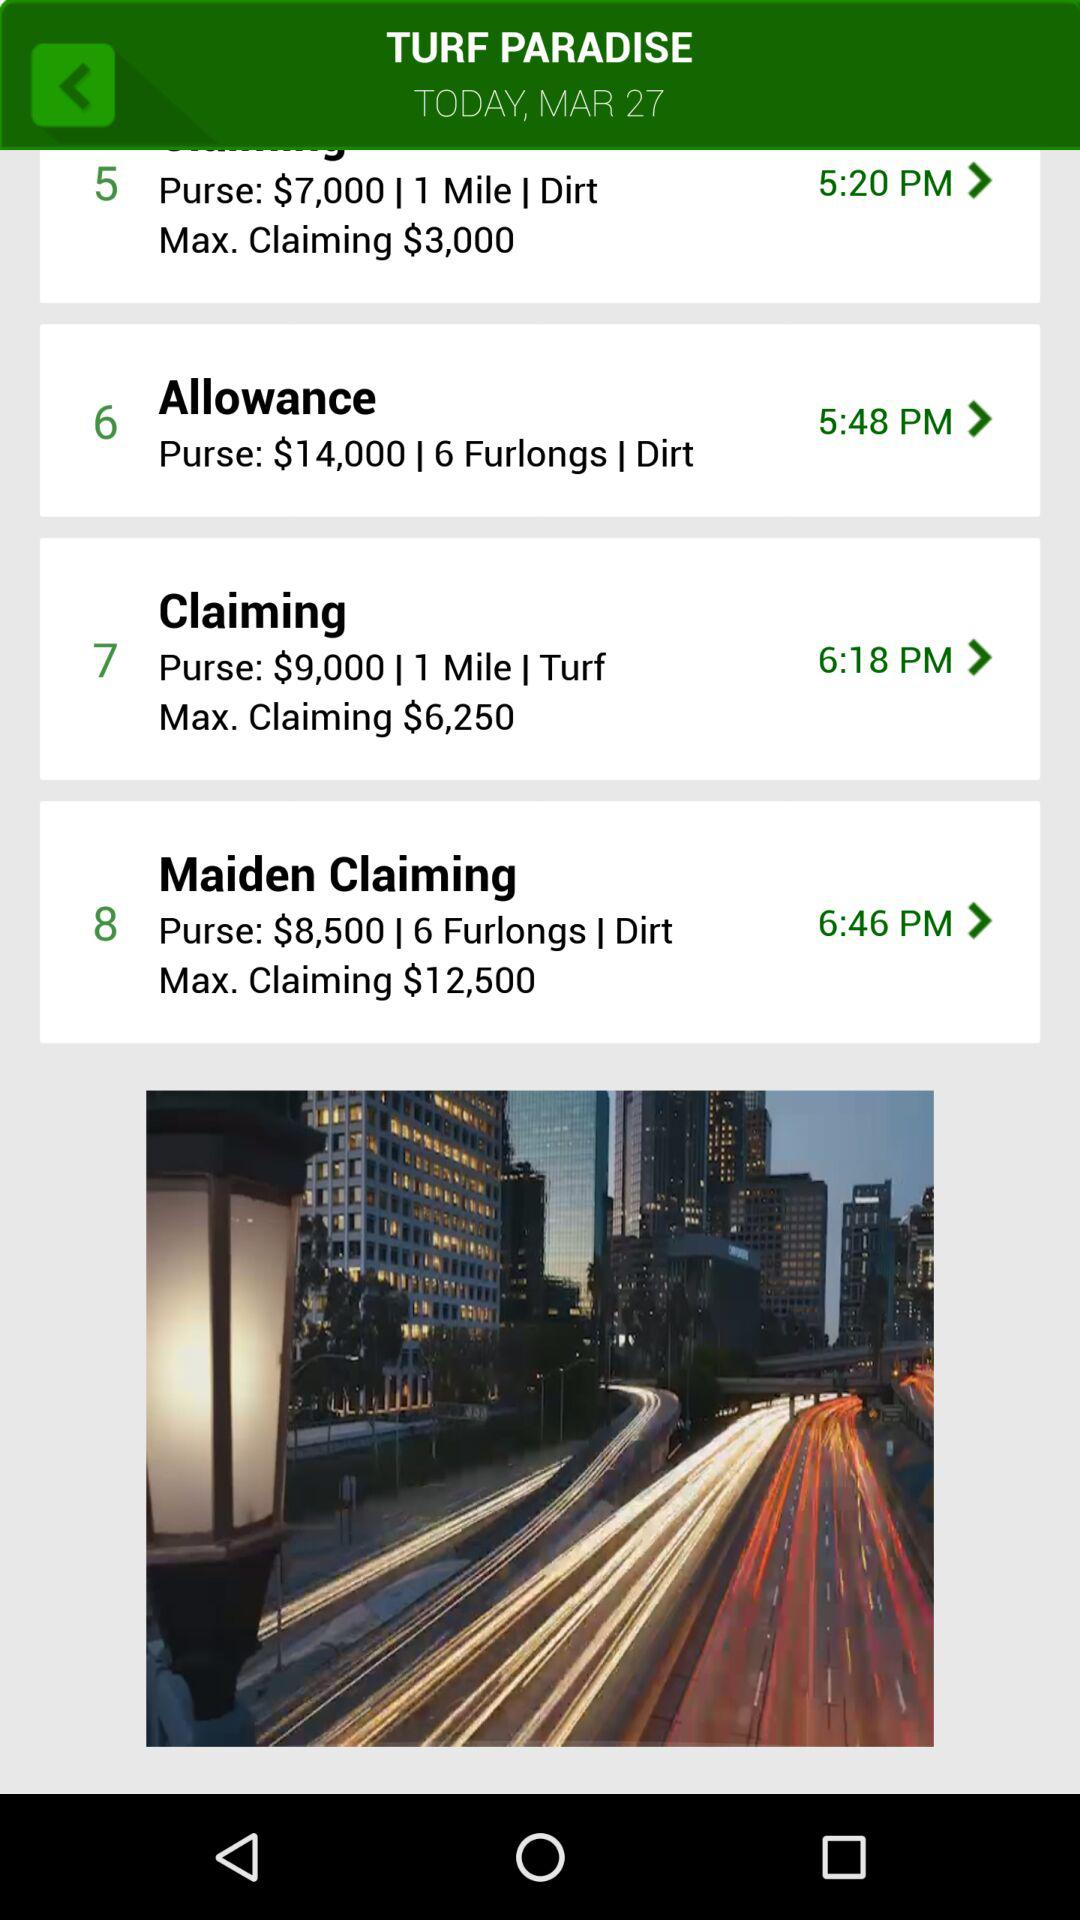How much money is in the purse for "Maiden Claiming"? The amount of money in the purse for "Maiden Claiming" is $8,500. 